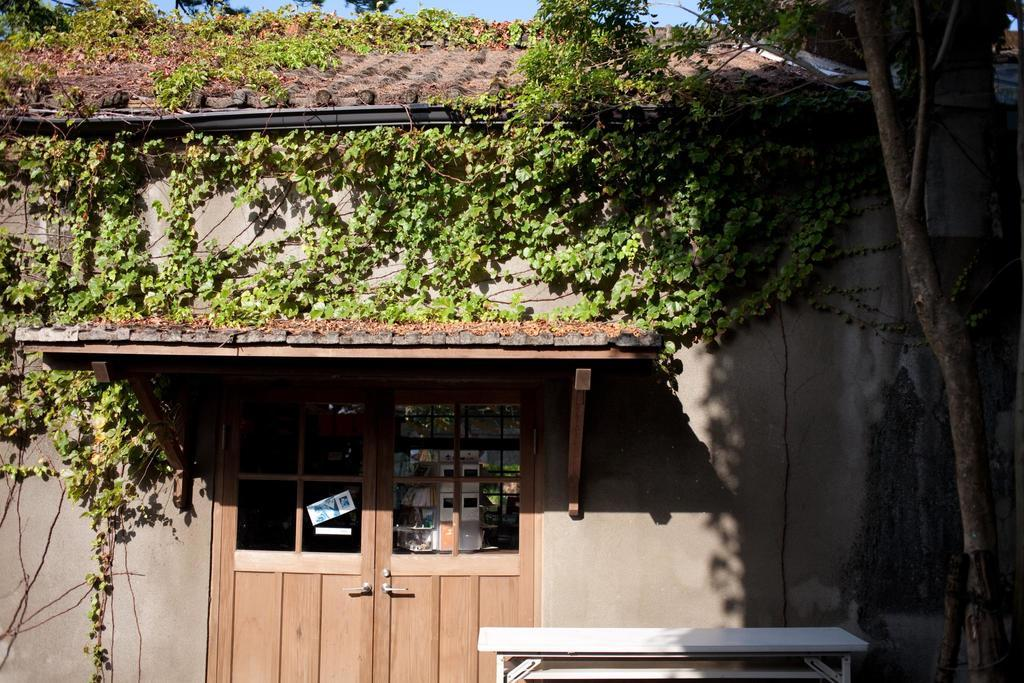What type of structure is visible in the image? There is a house in the image. What color is the door of the house? The door of the house is brown. What can be seen on the right side of the image? There is a tree on the right side of the image. What type of stage can be seen in the image? There is no stage present in the image; it features a house and a tree. What type of fear is depicted in the image? There is no fear depicted in the image; it is a scene of a house and a tree. 